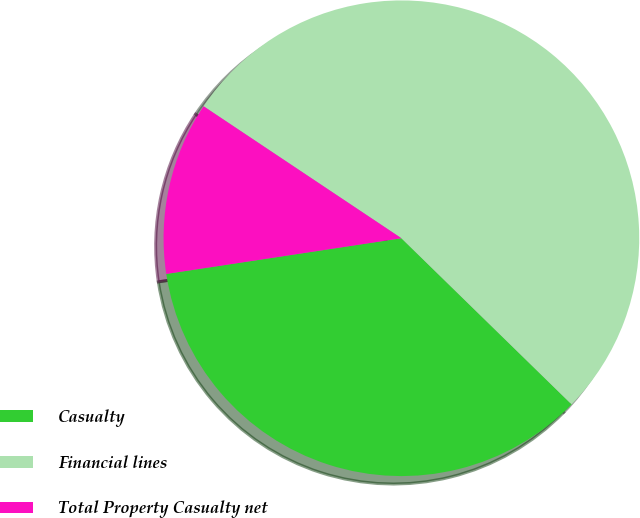Convert chart. <chart><loc_0><loc_0><loc_500><loc_500><pie_chart><fcel>Casualty<fcel>Financial lines<fcel>Total Property Casualty net<nl><fcel>35.29%<fcel>52.94%<fcel>11.76%<nl></chart> 